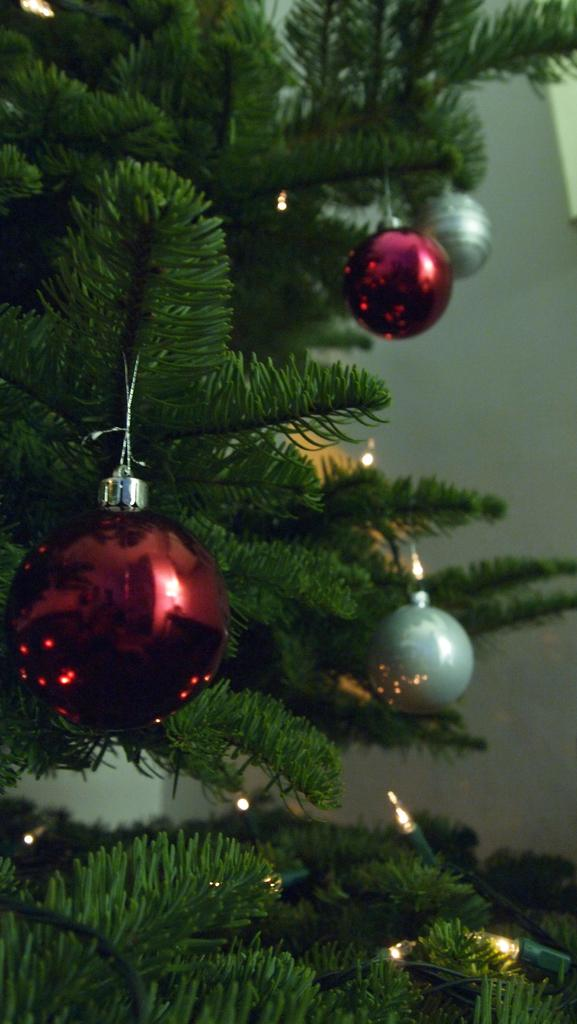What type of tree is in the image? There is an artificial tree in the image. How is the tree decorated? The tree is decorated with balls and lights. What can be seen in the background of the image? There is a wall in the background of the image. What type of pollution can be seen around the tree in the image? There is no pollution visible in the image; it only features an artificial tree decorated with balls and lights. Is there a crown visible on the tree in the image? No, there is no crown present on the tree in the image. 